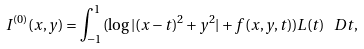Convert formula to latex. <formula><loc_0><loc_0><loc_500><loc_500>I ^ { ( 0 ) } ( x , y ) = \int _ { - 1 } ^ { 1 } ( \log | ( x - t ) ^ { 2 } + y ^ { 2 } | + f ( x , y , t ) ) L ( t ) \, \ D t ,</formula> 